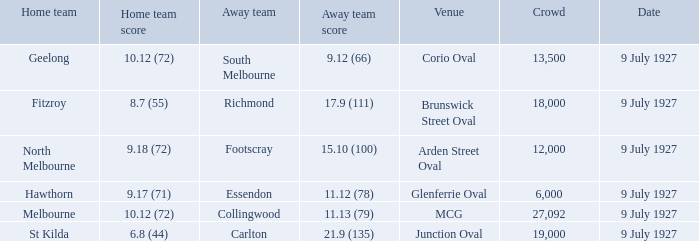Who was the away team playing the home team North Melbourne? Footscray. 